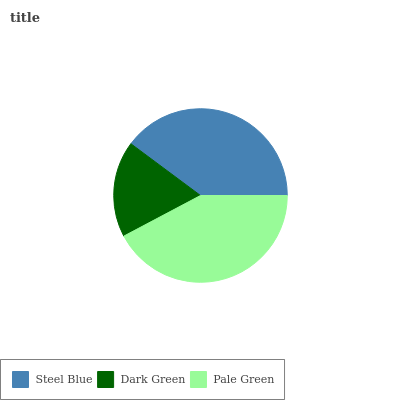Is Dark Green the minimum?
Answer yes or no. Yes. Is Pale Green the maximum?
Answer yes or no. Yes. Is Pale Green the minimum?
Answer yes or no. No. Is Dark Green the maximum?
Answer yes or no. No. Is Pale Green greater than Dark Green?
Answer yes or no. Yes. Is Dark Green less than Pale Green?
Answer yes or no. Yes. Is Dark Green greater than Pale Green?
Answer yes or no. No. Is Pale Green less than Dark Green?
Answer yes or no. No. Is Steel Blue the high median?
Answer yes or no. Yes. Is Steel Blue the low median?
Answer yes or no. Yes. Is Pale Green the high median?
Answer yes or no. No. Is Dark Green the low median?
Answer yes or no. No. 